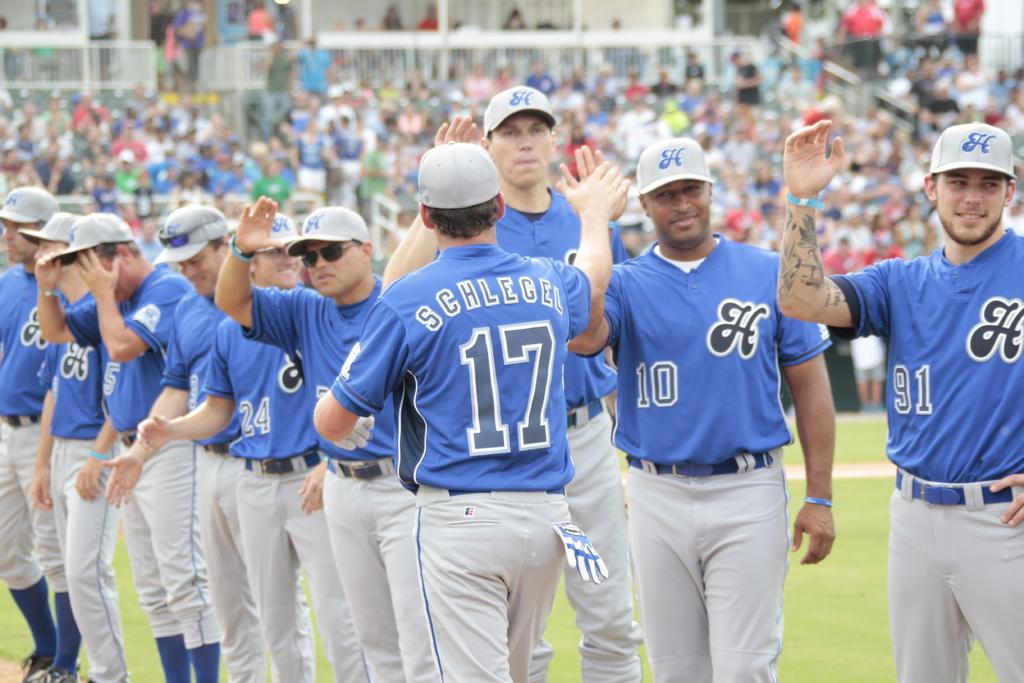<image>
Summarize the visual content of the image. Baseball player wearing jersey number 17 giving high fives. 